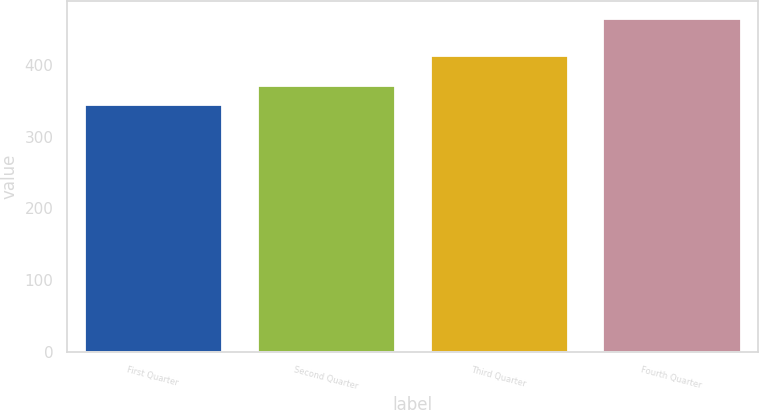Convert chart to OTSL. <chart><loc_0><loc_0><loc_500><loc_500><bar_chart><fcel>First Quarter<fcel>Second Quarter<fcel>Third Quarter<fcel>Fourth Quarter<nl><fcel>345.27<fcel>372.11<fcel>413.73<fcel>466.03<nl></chart> 